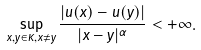<formula> <loc_0><loc_0><loc_500><loc_500>\sup _ { x , y \in K , x \neq y } \frac { | u ( x ) - u ( y ) | } { | x - y | ^ { \alpha } } < + \infty .</formula> 